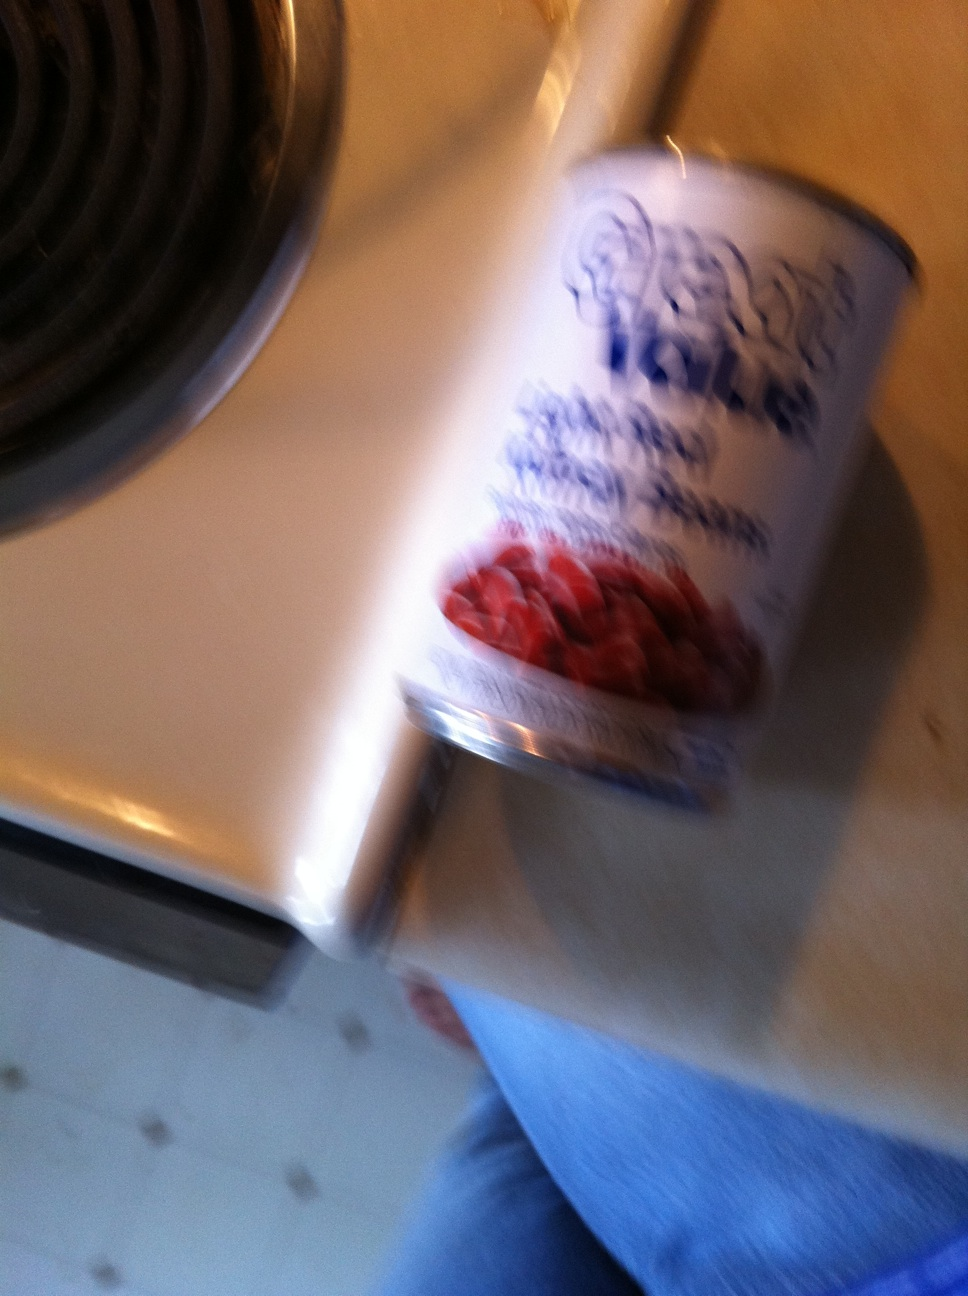What nutritional benefits do beans provide? Beans are nutritious, providing a good source of protein, dietary fiber, and various vitamins and minerals including iron, folate, and potassium. They are also low in fat, making them a healthy addition to any diet. 